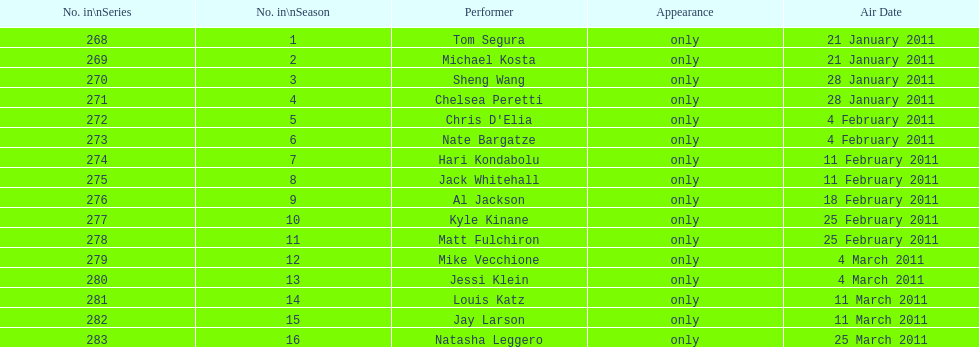What is the name of the last performer on this chart? Natasha Leggero. 